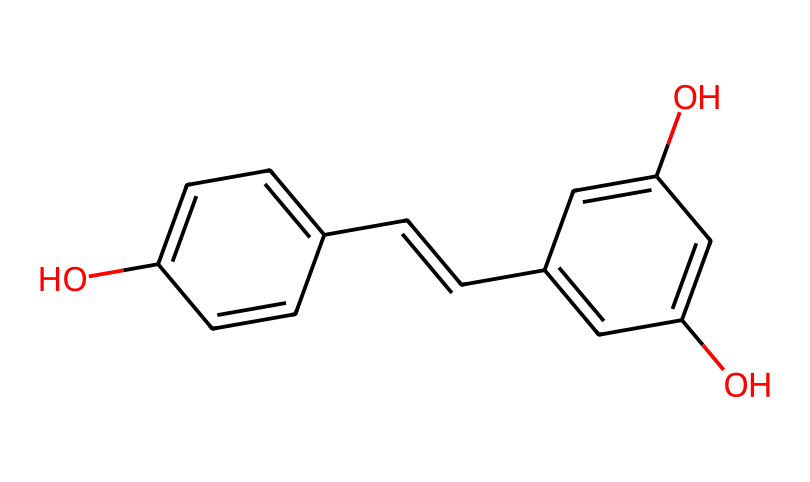What is the molecular formula of resveratrol? To find the molecular formula, count the number of carbon (C), hydrogen (H), and oxygen (O) atoms present in the SMILES representation. The structure indicates there are 14 carbon atoms, 12 hydrogen atoms, and 4 oxygen atoms, which gives a molecular formula of C14H12O4.
Answer: C14H12O4 How many hydroxyl (−OH) groups are present in resveratrol? By examining the structure, we can identify the functional groups. The structure shows two hydroxyl groups (−OH) attached to the aromatic rings at specific positions.
Answer: 2 What type of chemical is resveratrol classified as? Based on its structure containing phenolic rings and multiple hydroxyl groups, resveratrol is classified as a polyphenol. This classification is supported by the presence of the multiple aromatic hydroxyl groups.
Answer: polyphenol How many double bonds are in resveratrol? Observing the structural representation, there are two double bonds present in the carbon backbone: one in the central chain and one between the two aromatic rings.
Answer: 2 What is the primary structural feature that contributes to the antioxidant properties of resveratrol? The presence of multiple hydroxyl groups (aromatic and aliphatic) contributes to the antioxidant properties by enabling the molecule to donate hydrogen atoms, neutralizing free radicals. The arrangement of these groups also influences its activity.
Answer: hydroxyl groups In which fruits or beverages is resveratrol predominantly found? Resveratrol is predominantly found in red wine and grapes, as indicated by its natural sources. The chemical structure relates to the compounds produced in these plants for protecting against stress and pathogens.
Answer: red wine and grapes 